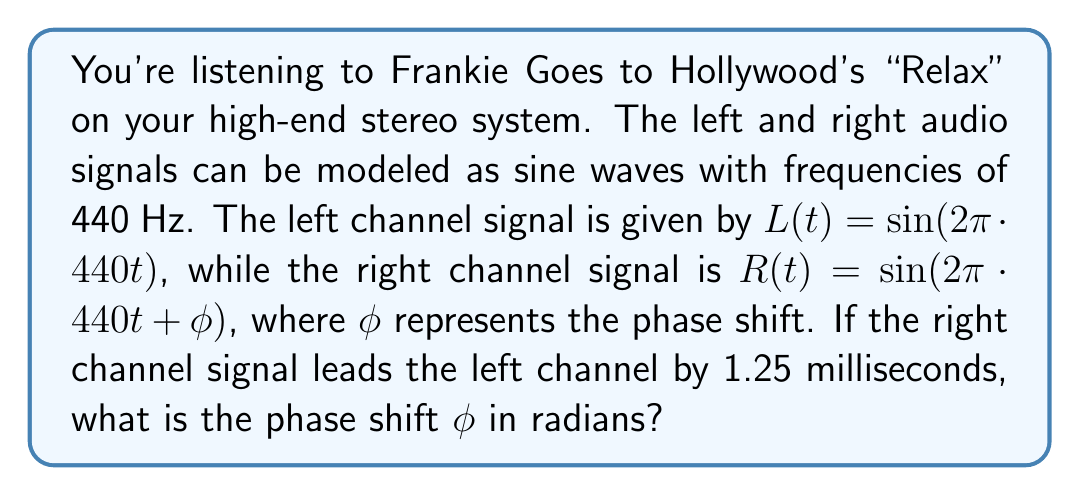Teach me how to tackle this problem. To solve this problem, we'll follow these steps:

1) First, we need to understand what a phase shift of 1.25 ms means in terms of the signal's period:
   
   The frequency is 440 Hz, so the period $T$ is:
   $$T = \frac{1}{f} = \frac{1}{440} \approx 0.002273 \text{ seconds}$$

2) The time shift of 1.25 ms can be expressed as a fraction of the period:
   $$\frac{0.00125}{0.002273} \approx 0.55$$

3) This means the right channel is shifted by approximately 0.55 of a full cycle.

4) In terms of angle, a full cycle corresponds to $2\pi$ radians. So, the phase shift $\phi$ is:
   $$\phi = 0.55 \cdot 2\pi \approx 3.4558 \text{ radians}$$

5) We can also express this more precisely:
   $$\phi = \frac{1.25 \cdot 10^{-3}}{1/440} \cdot 2\pi = 1.25 \cdot 10^{-3} \cdot 440 \cdot 2\pi \approx 3.4558 \text{ radians}$$

This phase shift causes the right channel signal to lead the left channel by 1.25 ms, creating the stereo effect in your high-fidelity playback of "Relax".
Answer: $\phi \approx 3.4558 \text{ radians}$ 